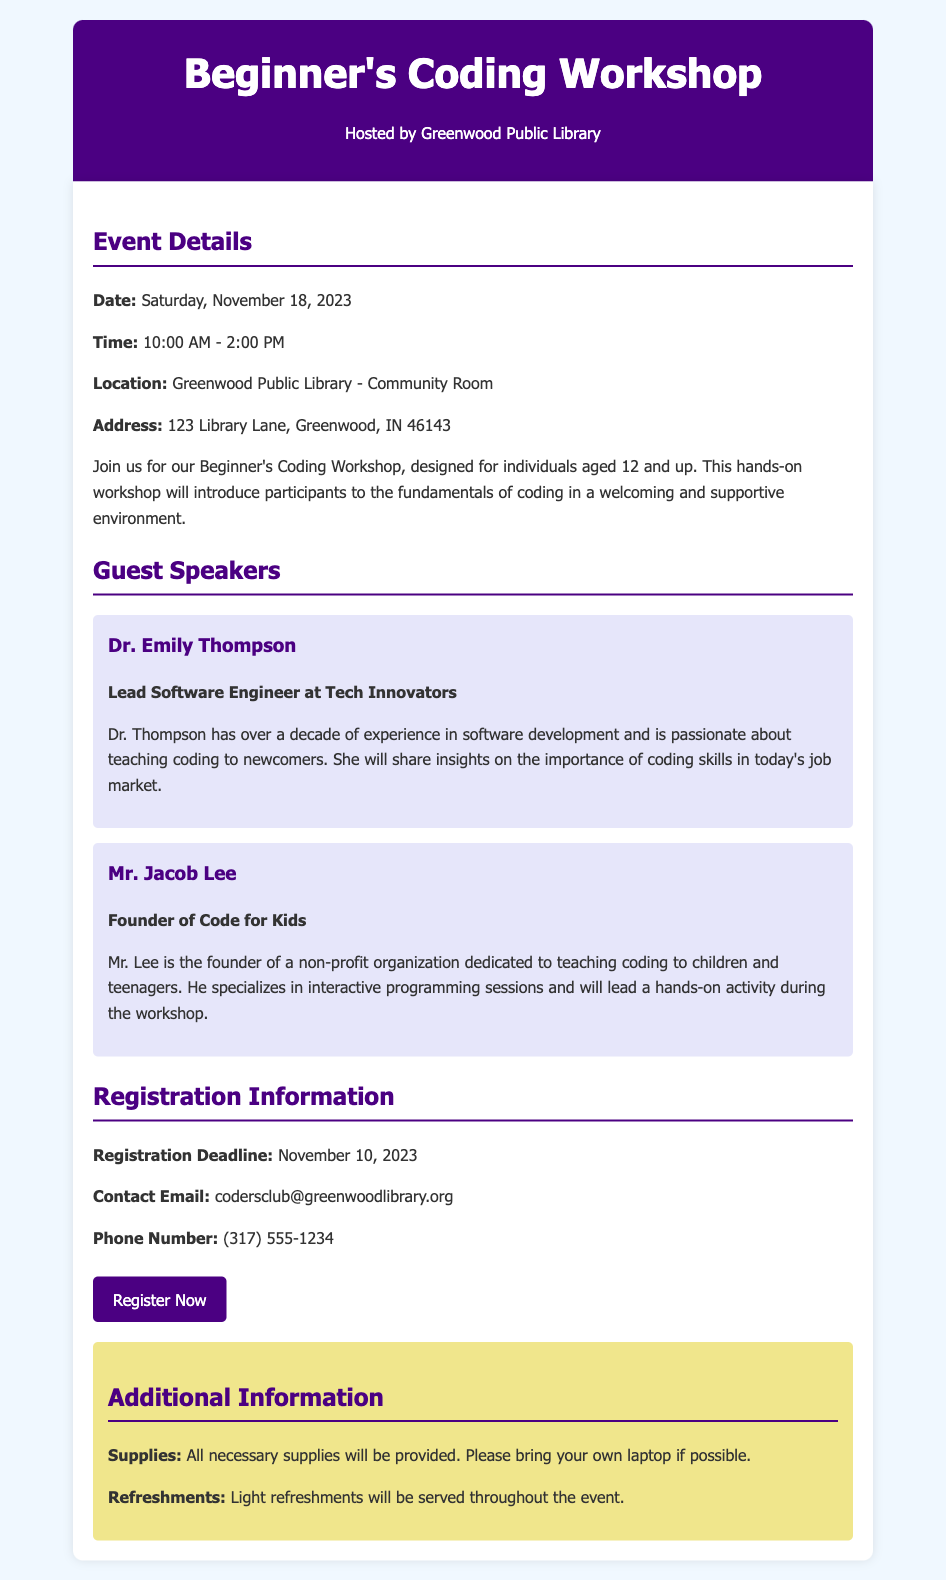What is the date of the workshop? The date of the workshop is clearly stated in the document as Saturday, November 18, 2023.
Answer: Saturday, November 18, 2023 What time does the workshop start? The document provides the starting time of the workshop, which is 10:00 AM.
Answer: 10:00 AM Who is the lead guest speaker? The document specifies Dr. Emily Thompson as the lead guest speaker for the workshop.
Answer: Dr. Emily Thompson What is the registration deadline? The registration deadline is mentioned under registration information as November 10, 2023.
Answer: November 10, 2023 What is the location of the event? The document gives the event location as Greenwood Public Library - Community Room.
Answer: Greenwood Public Library - Community Room Who will be leading a hands-on activity? The document states that Mr. Jacob Lee will lead a hands-on activity during the workshop.
Answer: Mr. Jacob Lee What is the contact email provided? The contact email for inquiries related to the workshop is stated in the registration information.
Answer: codersclub@greenwoodlibrary.org What supplies should participants bring? The document indicates that participants should bring their own laptops if possible.
Answer: Their own laptops What type of refreshments will be served? The document mentions that light refreshments will be served throughout the event.
Answer: Light refreshments 